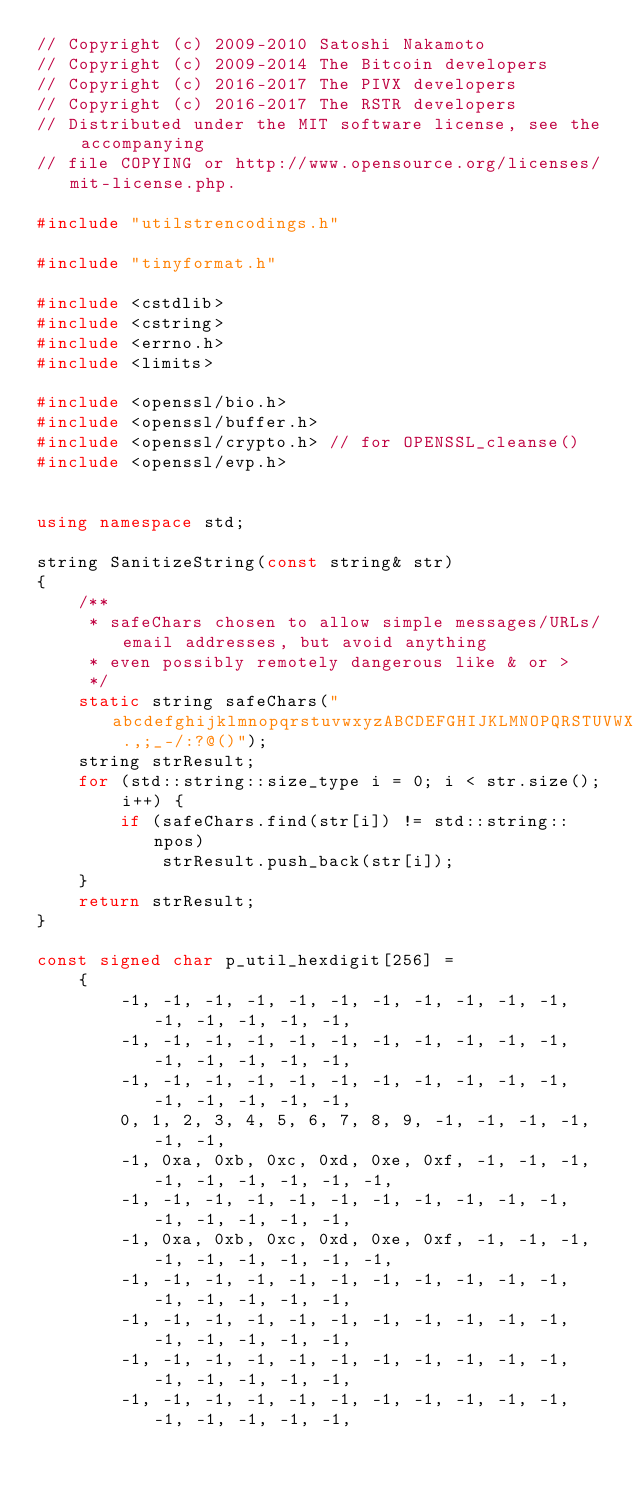<code> <loc_0><loc_0><loc_500><loc_500><_C++_>// Copyright (c) 2009-2010 Satoshi Nakamoto
// Copyright (c) 2009-2014 The Bitcoin developers
// Copyright (c) 2016-2017 The PIVX developers
// Copyright (c) 2016-2017 The RSTR developers
// Distributed under the MIT software license, see the accompanying
// file COPYING or http://www.opensource.org/licenses/mit-license.php.

#include "utilstrencodings.h"

#include "tinyformat.h"

#include <cstdlib>
#include <cstring>
#include <errno.h>
#include <limits>

#include <openssl/bio.h>
#include <openssl/buffer.h>
#include <openssl/crypto.h> // for OPENSSL_cleanse()
#include <openssl/evp.h>


using namespace std;

string SanitizeString(const string& str)
{
    /**
     * safeChars chosen to allow simple messages/URLs/email addresses, but avoid anything
     * even possibly remotely dangerous like & or >
     */
    static string safeChars("abcdefghijklmnopqrstuvwxyzABCDEFGHIJKLMNOPQRSTUVWXYZ01234567890 .,;_-/:?@()");
    string strResult;
    for (std::string::size_type i = 0; i < str.size(); i++) {
        if (safeChars.find(str[i]) != std::string::npos)
            strResult.push_back(str[i]);
    }
    return strResult;
}

const signed char p_util_hexdigit[256] =
    {
        -1, -1, -1, -1, -1, -1, -1, -1, -1, -1, -1, -1, -1, -1, -1, -1,
        -1, -1, -1, -1, -1, -1, -1, -1, -1, -1, -1, -1, -1, -1, -1, -1,
        -1, -1, -1, -1, -1, -1, -1, -1, -1, -1, -1, -1, -1, -1, -1, -1,
        0, 1, 2, 3, 4, 5, 6, 7, 8, 9, -1, -1, -1, -1, -1, -1,
        -1, 0xa, 0xb, 0xc, 0xd, 0xe, 0xf, -1, -1, -1, -1, -1, -1, -1, -1, -1,
        -1, -1, -1, -1, -1, -1, -1, -1, -1, -1, -1, -1, -1, -1, -1, -1,
        -1, 0xa, 0xb, 0xc, 0xd, 0xe, 0xf, -1, -1, -1, -1, -1, -1, -1, -1, -1,
        -1, -1, -1, -1, -1, -1, -1, -1, -1, -1, -1, -1, -1, -1, -1, -1,
        -1, -1, -1, -1, -1, -1, -1, -1, -1, -1, -1, -1, -1, -1, -1, -1,
        -1, -1, -1, -1, -1, -1, -1, -1, -1, -1, -1, -1, -1, -1, -1, -1,
        -1, -1, -1, -1, -1, -1, -1, -1, -1, -1, -1, -1, -1, -1, -1, -1,</code> 